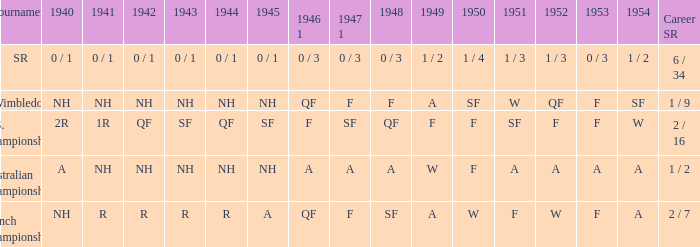I'm looking to parse the entire table for insights. Could you assist me with that? {'header': ['Tournament', '1940', '1941', '1942', '1943', '1944', '1945', '1946 1', '1947 1', '1948', '1949', '1950', '1951', '1952', '1953', '1954', 'Career SR'], 'rows': [['SR', '0 / 1', '0 / 1', '0 / 1', '0 / 1', '0 / 1', '0 / 1', '0 / 3', '0 / 3', '0 / 3', '1 / 2', '1 / 4', '1 / 3', '1 / 3', '0 / 3', '1 / 2', '6 / 34'], ['Wimbledon', 'NH', 'NH', 'NH', 'NH', 'NH', 'NH', 'QF', 'F', 'F', 'A', 'SF', 'W', 'QF', 'F', 'SF', '1 / 9'], ['U.S. Championships', '2R', '1R', 'QF', 'SF', 'QF', 'SF', 'F', 'SF', 'QF', 'F', 'F', 'SF', 'F', 'F', 'W', '2 / 16'], ['Australian Championships', 'A', 'NH', 'NH', 'NH', 'NH', 'NH', 'A', 'A', 'A', 'W', 'F', 'A', 'A', 'A', 'A', '1 / 2'], ['French Championships', 'NH', 'R', 'R', 'R', 'R', 'A', 'QF', 'F', 'SF', 'A', 'W', 'F', 'W', 'F', 'A', '2 / 7']]} What is the 1944 outcome for the u.s. championships? QF. 